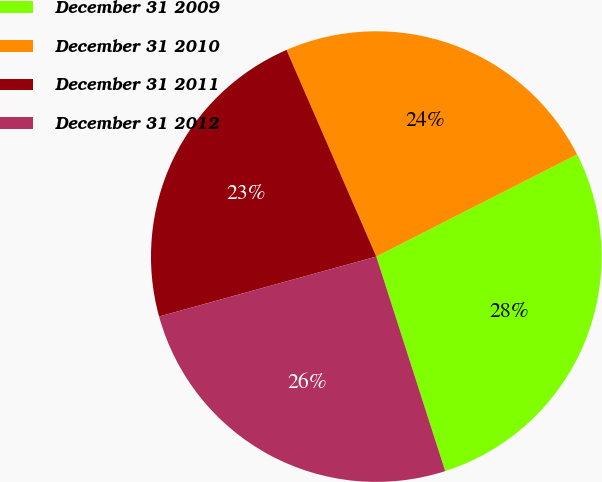Convert chart to OTSL. <chart><loc_0><loc_0><loc_500><loc_500><pie_chart><fcel>December 31 2009<fcel>December 31 2010<fcel>December 31 2011<fcel>December 31 2012<nl><fcel>27.54%<fcel>24.03%<fcel>22.76%<fcel>25.66%<nl></chart> 